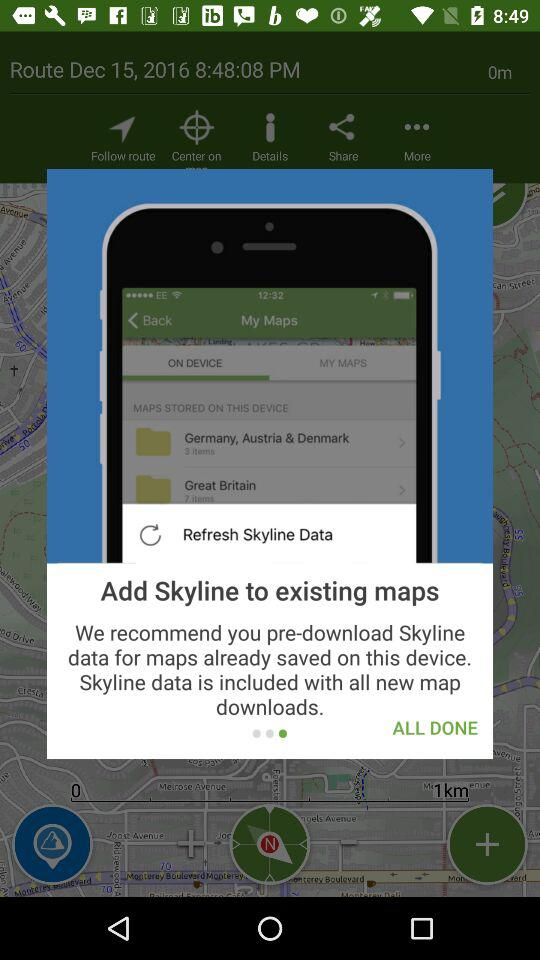How many steps are there in the process of adding Skyline to existing maps?
Answer the question using a single word or phrase. 3 